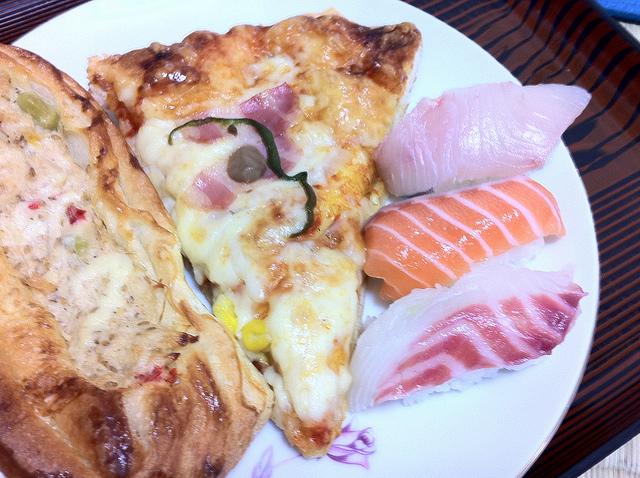What meat is in that?
Give a very brief answer. Fish. Is it common to eat pizza and sashimi together?
Short answer required. No. Is there any pepperoni on the slice of pizza?
Answer briefly. No. What is the food on the right?
Give a very brief answer. Sushi. 